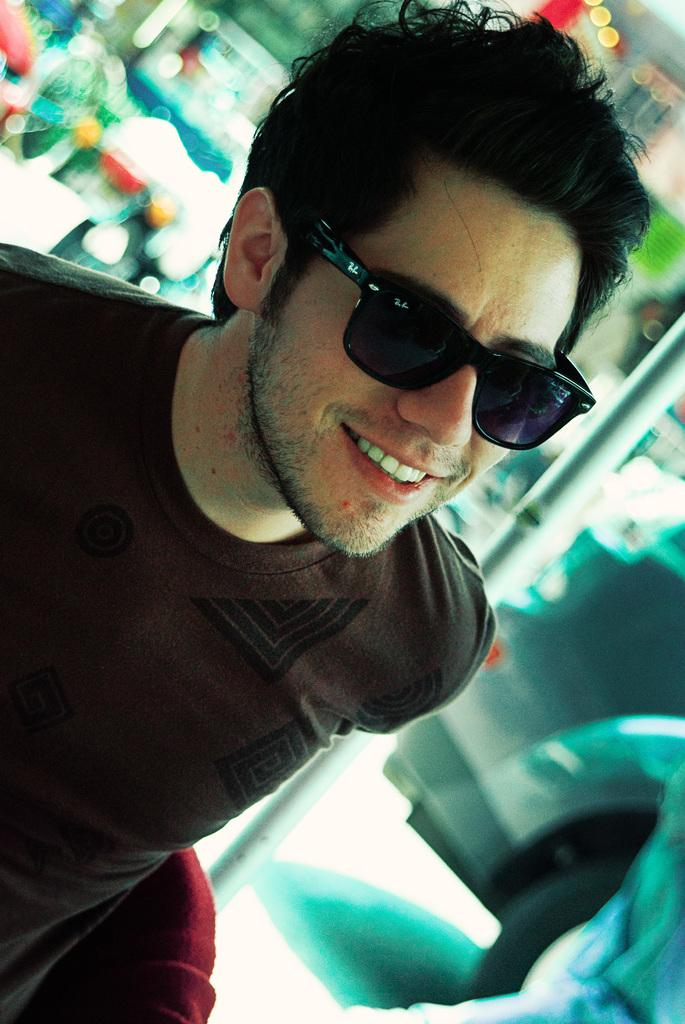Who is present in the image? There is a man in the image. What is the man wearing that is noticeable? The man is wearing black color spectacles. What can be seen on the right side of the image? There is a car on the right side of the image. Where is the car located in the image? The car is on the road. Can you see a sponge floating in the lake in the image? There is no lake or sponge present in the image. 